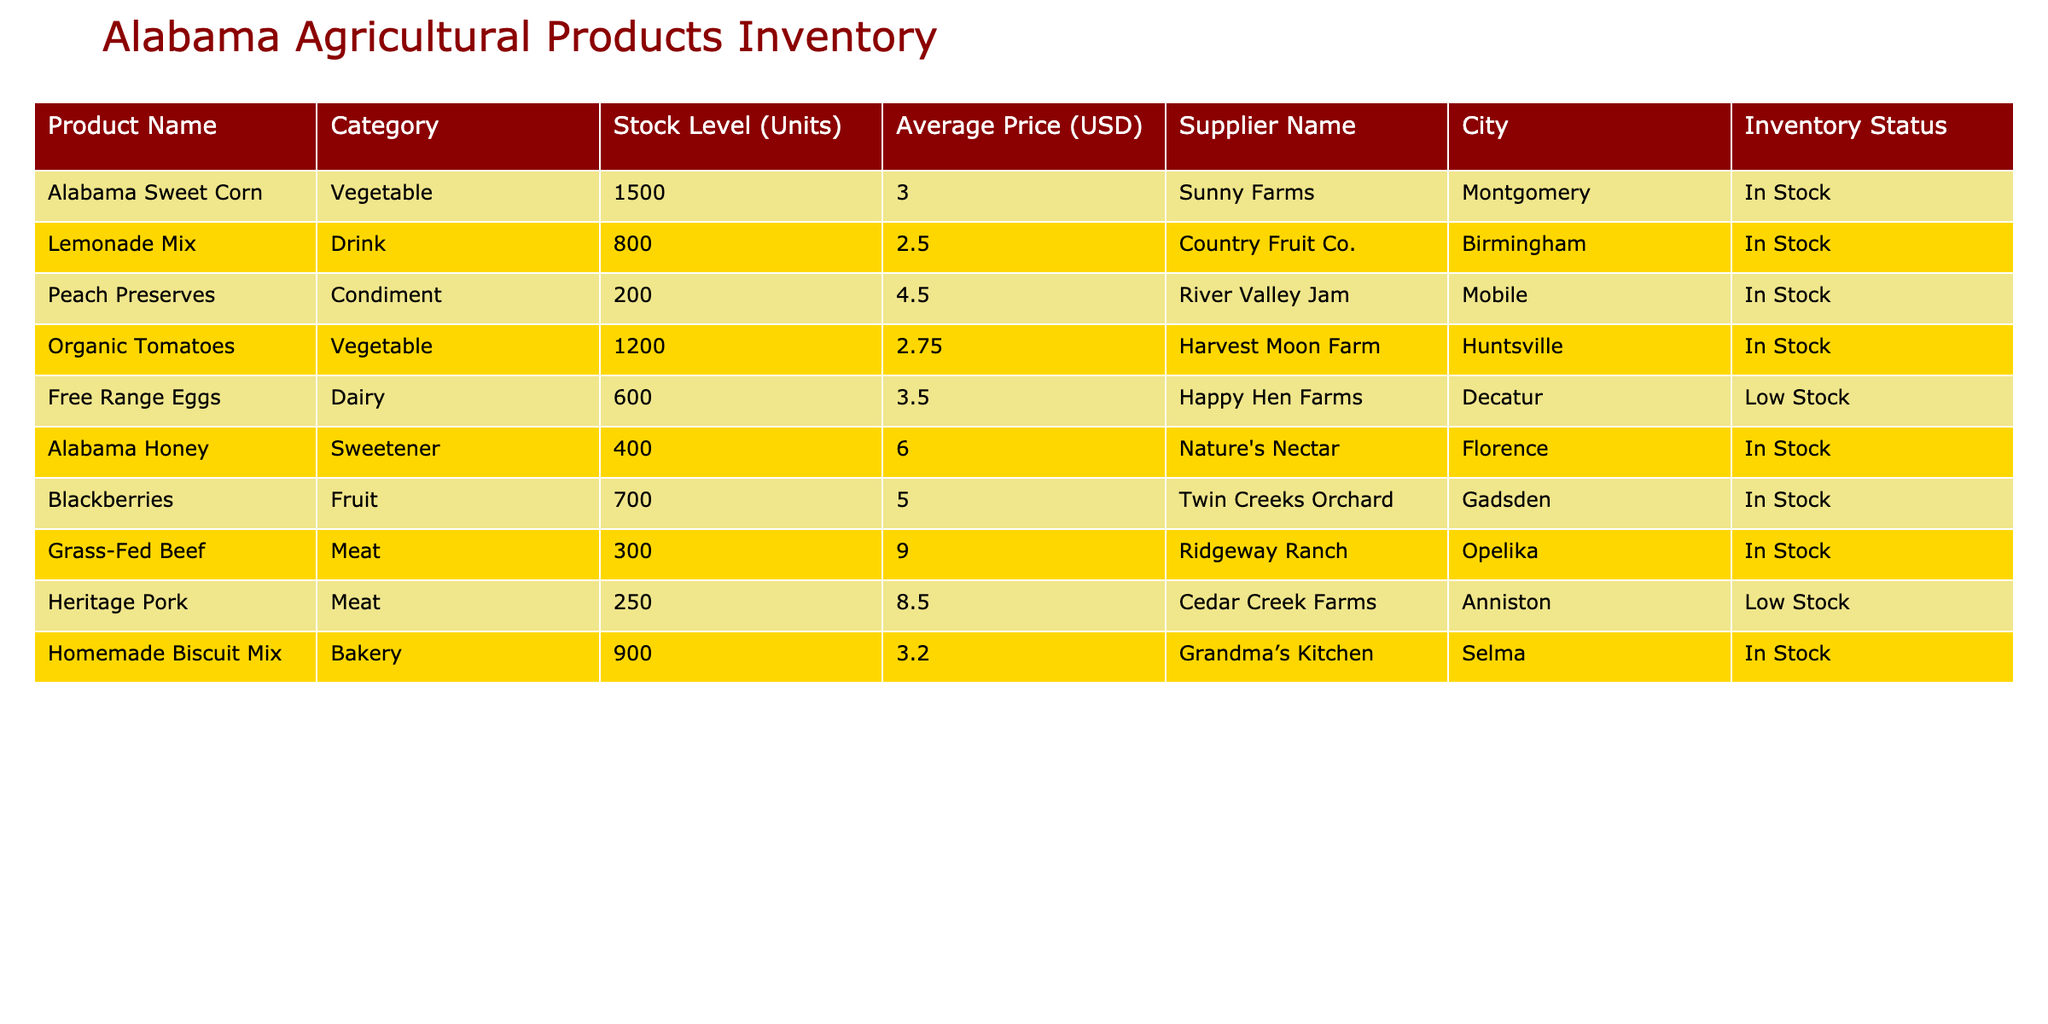What is the stock level of Alabama Sweet Corn? The stock level for Alabama Sweet Corn is directly listed in the table under the "Stock Level (Units)" column, which shows 1500 units.
Answer: 1500 Which product has the highest average price? By comparing the values in the "Average Price (USD)" column, Grass-Fed Beef has the highest price at 9.00 USD.
Answer: Grass-Fed Beef Is the stock level of Free Range Eggs high or low? The table indicates that the "Inventory Status" for Free Range Eggs is "Low Stock," meaning there are fewer units available compared to others.
Answer: Low Stock What is the combined stock level of Organic Tomatoes and Blackberries? The stock level of Organic Tomatoes is 1200 units and Blackberries is 700 units. Adding them gives 1200 + 700 = 1900 units combined.
Answer: 1900 Does any supplier have products listed as Low Stock? Yes, both Free Range Eggs and Heritage Pork are listed with the status of Low Stock in the table.
Answer: Yes What is the average price of all dairy products listed? There is only one dairy product listed: Free Range Eggs at an average price of 3.50 USD. Therefore, the average price of dairy products is 3.50 USD.
Answer: 3.50 What is the difference in stock levels between Heritage Pork and Grass-Fed Beef? Heritage Pork has a stock level of 250 units and Grass-Fed Beef has 300 units. The difference is 300 - 250 = 50 units, indicating Grass-Fed Beef has 50 more units in stock.
Answer: 50 How many products are in stock with a price greater than 5.00 USD? The products with prices greater than 5.00 USD are Alabama Honey (400 units), Blackberries (700 units), and Grass-Fed Beef (300 units)—totaling 3 products.
Answer: 3 What is the total stock of all the vegetable products combined? The stock levels for vegetable products are Alabama Sweet Corn (1500), Organic Tomatoes (1200). Adding these gives 1500 + 1200 = 2700 units total for vegetable products.
Answer: 2700 